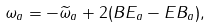<formula> <loc_0><loc_0><loc_500><loc_500>\omega _ { a } = - \widetilde { \omega } _ { a } + 2 ( B E _ { a } - E B _ { a } ) ,</formula> 